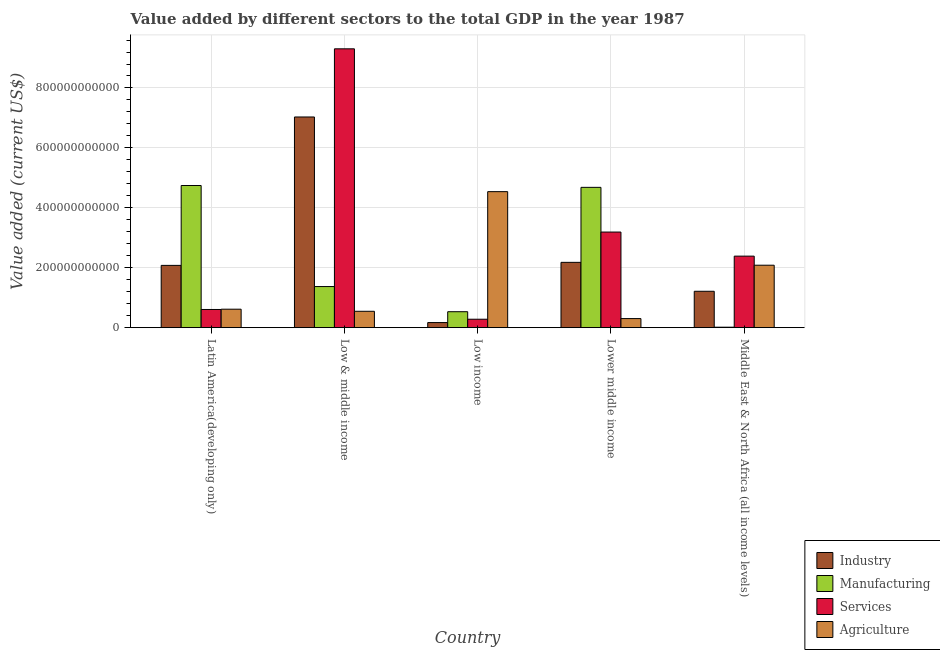How many groups of bars are there?
Your answer should be very brief. 5. How many bars are there on the 3rd tick from the left?
Your answer should be very brief. 4. What is the label of the 1st group of bars from the left?
Your response must be concise. Latin America(developing only). What is the value added by services sector in Middle East & North Africa (all income levels)?
Give a very brief answer. 2.39e+11. Across all countries, what is the maximum value added by industrial sector?
Give a very brief answer. 7.03e+11. Across all countries, what is the minimum value added by agricultural sector?
Give a very brief answer. 3.03e+1. In which country was the value added by agricultural sector maximum?
Give a very brief answer. Low income. In which country was the value added by agricultural sector minimum?
Give a very brief answer. Lower middle income. What is the total value added by manufacturing sector in the graph?
Your answer should be compact. 1.13e+12. What is the difference between the value added by industrial sector in Low & middle income and that in Middle East & North Africa (all income levels)?
Give a very brief answer. 5.82e+11. What is the difference between the value added by services sector in Low income and the value added by manufacturing sector in Middle East & North Africa (all income levels)?
Ensure brevity in your answer.  2.66e+1. What is the average value added by services sector per country?
Give a very brief answer. 3.15e+11. What is the difference between the value added by agricultural sector and value added by services sector in Middle East & North Africa (all income levels)?
Your response must be concise. -3.03e+1. What is the ratio of the value added by agricultural sector in Low & middle income to that in Low income?
Ensure brevity in your answer.  0.12. What is the difference between the highest and the second highest value added by industrial sector?
Offer a terse response. 4.85e+11. What is the difference between the highest and the lowest value added by agricultural sector?
Your answer should be compact. 4.24e+11. In how many countries, is the value added by services sector greater than the average value added by services sector taken over all countries?
Make the answer very short. 2. Is the sum of the value added by manufacturing sector in Low income and Middle East & North Africa (all income levels) greater than the maximum value added by services sector across all countries?
Give a very brief answer. No. Is it the case that in every country, the sum of the value added by services sector and value added by industrial sector is greater than the sum of value added by agricultural sector and value added by manufacturing sector?
Offer a terse response. No. What does the 1st bar from the left in Middle East & North Africa (all income levels) represents?
Provide a succinct answer. Industry. What does the 1st bar from the right in Low & middle income represents?
Your answer should be compact. Agriculture. Are all the bars in the graph horizontal?
Provide a succinct answer. No. How many countries are there in the graph?
Your answer should be very brief. 5. What is the difference between two consecutive major ticks on the Y-axis?
Provide a short and direct response. 2.00e+11. Are the values on the major ticks of Y-axis written in scientific E-notation?
Give a very brief answer. No. How are the legend labels stacked?
Your answer should be compact. Vertical. What is the title of the graph?
Keep it short and to the point. Value added by different sectors to the total GDP in the year 1987. Does "UNRWA" appear as one of the legend labels in the graph?
Your answer should be compact. No. What is the label or title of the X-axis?
Ensure brevity in your answer.  Country. What is the label or title of the Y-axis?
Offer a terse response. Value added (current US$). What is the Value added (current US$) of Industry in Latin America(developing only)?
Make the answer very short. 2.08e+11. What is the Value added (current US$) in Manufacturing in Latin America(developing only)?
Your answer should be compact. 4.74e+11. What is the Value added (current US$) of Services in Latin America(developing only)?
Your answer should be compact. 6.07e+1. What is the Value added (current US$) of Agriculture in Latin America(developing only)?
Give a very brief answer. 6.17e+1. What is the Value added (current US$) of Industry in Low & middle income?
Offer a very short reply. 7.03e+11. What is the Value added (current US$) of Manufacturing in Low & middle income?
Your answer should be compact. 1.37e+11. What is the Value added (current US$) of Services in Low & middle income?
Provide a succinct answer. 9.31e+11. What is the Value added (current US$) of Agriculture in Low & middle income?
Your answer should be very brief. 5.47e+1. What is the Value added (current US$) in Industry in Low income?
Offer a terse response. 1.70e+1. What is the Value added (current US$) of Manufacturing in Low income?
Offer a very short reply. 5.32e+1. What is the Value added (current US$) in Services in Low income?
Your answer should be compact. 2.82e+1. What is the Value added (current US$) in Agriculture in Low income?
Make the answer very short. 4.54e+11. What is the Value added (current US$) of Industry in Lower middle income?
Keep it short and to the point. 2.18e+11. What is the Value added (current US$) in Manufacturing in Lower middle income?
Offer a very short reply. 4.68e+11. What is the Value added (current US$) of Services in Lower middle income?
Give a very brief answer. 3.19e+11. What is the Value added (current US$) of Agriculture in Lower middle income?
Ensure brevity in your answer.  3.03e+1. What is the Value added (current US$) of Industry in Middle East & North Africa (all income levels)?
Your answer should be very brief. 1.21e+11. What is the Value added (current US$) in Manufacturing in Middle East & North Africa (all income levels)?
Your answer should be very brief. 1.57e+09. What is the Value added (current US$) of Services in Middle East & North Africa (all income levels)?
Give a very brief answer. 2.39e+11. What is the Value added (current US$) of Agriculture in Middle East & North Africa (all income levels)?
Your answer should be compact. 2.08e+11. Across all countries, what is the maximum Value added (current US$) of Industry?
Your answer should be compact. 7.03e+11. Across all countries, what is the maximum Value added (current US$) of Manufacturing?
Make the answer very short. 4.74e+11. Across all countries, what is the maximum Value added (current US$) of Services?
Your answer should be compact. 9.31e+11. Across all countries, what is the maximum Value added (current US$) of Agriculture?
Your answer should be compact. 4.54e+11. Across all countries, what is the minimum Value added (current US$) of Industry?
Make the answer very short. 1.70e+1. Across all countries, what is the minimum Value added (current US$) in Manufacturing?
Give a very brief answer. 1.57e+09. Across all countries, what is the minimum Value added (current US$) of Services?
Provide a short and direct response. 2.82e+1. Across all countries, what is the minimum Value added (current US$) in Agriculture?
Provide a short and direct response. 3.03e+1. What is the total Value added (current US$) in Industry in the graph?
Provide a short and direct response. 1.27e+12. What is the total Value added (current US$) in Manufacturing in the graph?
Offer a very short reply. 1.13e+12. What is the total Value added (current US$) in Services in the graph?
Your response must be concise. 1.58e+12. What is the total Value added (current US$) in Agriculture in the graph?
Give a very brief answer. 8.09e+11. What is the difference between the Value added (current US$) of Industry in Latin America(developing only) and that in Low & middle income?
Your answer should be compact. -4.95e+11. What is the difference between the Value added (current US$) in Manufacturing in Latin America(developing only) and that in Low & middle income?
Offer a very short reply. 3.37e+11. What is the difference between the Value added (current US$) in Services in Latin America(developing only) and that in Low & middle income?
Provide a succinct answer. -8.70e+11. What is the difference between the Value added (current US$) of Agriculture in Latin America(developing only) and that in Low & middle income?
Ensure brevity in your answer.  7.00e+09. What is the difference between the Value added (current US$) in Industry in Latin America(developing only) and that in Low income?
Your response must be concise. 1.91e+11. What is the difference between the Value added (current US$) of Manufacturing in Latin America(developing only) and that in Low income?
Offer a very short reply. 4.21e+11. What is the difference between the Value added (current US$) in Services in Latin America(developing only) and that in Low income?
Make the answer very short. 3.25e+1. What is the difference between the Value added (current US$) of Agriculture in Latin America(developing only) and that in Low income?
Provide a short and direct response. -3.92e+11. What is the difference between the Value added (current US$) in Industry in Latin America(developing only) and that in Lower middle income?
Your answer should be very brief. -1.01e+1. What is the difference between the Value added (current US$) in Manufacturing in Latin America(developing only) and that in Lower middle income?
Keep it short and to the point. 6.17e+09. What is the difference between the Value added (current US$) in Services in Latin America(developing only) and that in Lower middle income?
Make the answer very short. -2.58e+11. What is the difference between the Value added (current US$) of Agriculture in Latin America(developing only) and that in Lower middle income?
Provide a succinct answer. 3.14e+1. What is the difference between the Value added (current US$) in Industry in Latin America(developing only) and that in Middle East & North Africa (all income levels)?
Keep it short and to the point. 8.64e+1. What is the difference between the Value added (current US$) in Manufacturing in Latin America(developing only) and that in Middle East & North Africa (all income levels)?
Make the answer very short. 4.73e+11. What is the difference between the Value added (current US$) in Services in Latin America(developing only) and that in Middle East & North Africa (all income levels)?
Your response must be concise. -1.78e+11. What is the difference between the Value added (current US$) of Agriculture in Latin America(developing only) and that in Middle East & North Africa (all income levels)?
Keep it short and to the point. -1.47e+11. What is the difference between the Value added (current US$) of Industry in Low & middle income and that in Low income?
Your response must be concise. 6.86e+11. What is the difference between the Value added (current US$) of Manufacturing in Low & middle income and that in Low income?
Give a very brief answer. 8.40e+1. What is the difference between the Value added (current US$) in Services in Low & middle income and that in Low income?
Make the answer very short. 9.03e+11. What is the difference between the Value added (current US$) of Agriculture in Low & middle income and that in Low income?
Provide a short and direct response. -3.99e+11. What is the difference between the Value added (current US$) of Industry in Low & middle income and that in Lower middle income?
Your response must be concise. 4.85e+11. What is the difference between the Value added (current US$) in Manufacturing in Low & middle income and that in Lower middle income?
Ensure brevity in your answer.  -3.31e+11. What is the difference between the Value added (current US$) of Services in Low & middle income and that in Lower middle income?
Ensure brevity in your answer.  6.12e+11. What is the difference between the Value added (current US$) in Agriculture in Low & middle income and that in Lower middle income?
Provide a succinct answer. 2.44e+1. What is the difference between the Value added (current US$) in Industry in Low & middle income and that in Middle East & North Africa (all income levels)?
Ensure brevity in your answer.  5.82e+11. What is the difference between the Value added (current US$) in Manufacturing in Low & middle income and that in Middle East & North Africa (all income levels)?
Your response must be concise. 1.36e+11. What is the difference between the Value added (current US$) in Services in Low & middle income and that in Middle East & North Africa (all income levels)?
Your answer should be compact. 6.92e+11. What is the difference between the Value added (current US$) in Agriculture in Low & middle income and that in Middle East & North Africa (all income levels)?
Keep it short and to the point. -1.54e+11. What is the difference between the Value added (current US$) of Industry in Low income and that in Lower middle income?
Make the answer very short. -2.01e+11. What is the difference between the Value added (current US$) of Manufacturing in Low income and that in Lower middle income?
Provide a succinct answer. -4.15e+11. What is the difference between the Value added (current US$) of Services in Low income and that in Lower middle income?
Provide a succinct answer. -2.91e+11. What is the difference between the Value added (current US$) of Agriculture in Low income and that in Lower middle income?
Offer a terse response. 4.24e+11. What is the difference between the Value added (current US$) in Industry in Low income and that in Middle East & North Africa (all income levels)?
Your answer should be compact. -1.04e+11. What is the difference between the Value added (current US$) in Manufacturing in Low income and that in Middle East & North Africa (all income levels)?
Your answer should be very brief. 5.17e+1. What is the difference between the Value added (current US$) in Services in Low income and that in Middle East & North Africa (all income levels)?
Provide a succinct answer. -2.11e+11. What is the difference between the Value added (current US$) in Agriculture in Low income and that in Middle East & North Africa (all income levels)?
Keep it short and to the point. 2.46e+11. What is the difference between the Value added (current US$) of Industry in Lower middle income and that in Middle East & North Africa (all income levels)?
Provide a short and direct response. 9.65e+1. What is the difference between the Value added (current US$) in Manufacturing in Lower middle income and that in Middle East & North Africa (all income levels)?
Offer a very short reply. 4.67e+11. What is the difference between the Value added (current US$) of Services in Lower middle income and that in Middle East & North Africa (all income levels)?
Your answer should be very brief. 8.04e+1. What is the difference between the Value added (current US$) in Agriculture in Lower middle income and that in Middle East & North Africa (all income levels)?
Your answer should be compact. -1.78e+11. What is the difference between the Value added (current US$) of Industry in Latin America(developing only) and the Value added (current US$) of Manufacturing in Low & middle income?
Your answer should be very brief. 7.07e+1. What is the difference between the Value added (current US$) of Industry in Latin America(developing only) and the Value added (current US$) of Services in Low & middle income?
Ensure brevity in your answer.  -7.23e+11. What is the difference between the Value added (current US$) of Industry in Latin America(developing only) and the Value added (current US$) of Agriculture in Low & middle income?
Your response must be concise. 1.53e+11. What is the difference between the Value added (current US$) of Manufacturing in Latin America(developing only) and the Value added (current US$) of Services in Low & middle income?
Provide a succinct answer. -4.56e+11. What is the difference between the Value added (current US$) of Manufacturing in Latin America(developing only) and the Value added (current US$) of Agriculture in Low & middle income?
Your answer should be compact. 4.20e+11. What is the difference between the Value added (current US$) of Services in Latin America(developing only) and the Value added (current US$) of Agriculture in Low & middle income?
Your response must be concise. 6.03e+09. What is the difference between the Value added (current US$) in Industry in Latin America(developing only) and the Value added (current US$) in Manufacturing in Low income?
Ensure brevity in your answer.  1.55e+11. What is the difference between the Value added (current US$) of Industry in Latin America(developing only) and the Value added (current US$) of Services in Low income?
Ensure brevity in your answer.  1.80e+11. What is the difference between the Value added (current US$) in Industry in Latin America(developing only) and the Value added (current US$) in Agriculture in Low income?
Provide a succinct answer. -2.46e+11. What is the difference between the Value added (current US$) in Manufacturing in Latin America(developing only) and the Value added (current US$) in Services in Low income?
Make the answer very short. 4.46e+11. What is the difference between the Value added (current US$) of Manufacturing in Latin America(developing only) and the Value added (current US$) of Agriculture in Low income?
Your answer should be very brief. 2.05e+1. What is the difference between the Value added (current US$) in Services in Latin America(developing only) and the Value added (current US$) in Agriculture in Low income?
Offer a terse response. -3.93e+11. What is the difference between the Value added (current US$) of Industry in Latin America(developing only) and the Value added (current US$) of Manufacturing in Lower middle income?
Your answer should be compact. -2.60e+11. What is the difference between the Value added (current US$) of Industry in Latin America(developing only) and the Value added (current US$) of Services in Lower middle income?
Offer a very short reply. -1.11e+11. What is the difference between the Value added (current US$) of Industry in Latin America(developing only) and the Value added (current US$) of Agriculture in Lower middle income?
Make the answer very short. 1.78e+11. What is the difference between the Value added (current US$) of Manufacturing in Latin America(developing only) and the Value added (current US$) of Services in Lower middle income?
Provide a succinct answer. 1.55e+11. What is the difference between the Value added (current US$) of Manufacturing in Latin America(developing only) and the Value added (current US$) of Agriculture in Lower middle income?
Your answer should be very brief. 4.44e+11. What is the difference between the Value added (current US$) in Services in Latin America(developing only) and the Value added (current US$) in Agriculture in Lower middle income?
Keep it short and to the point. 3.04e+1. What is the difference between the Value added (current US$) of Industry in Latin America(developing only) and the Value added (current US$) of Manufacturing in Middle East & North Africa (all income levels)?
Ensure brevity in your answer.  2.06e+11. What is the difference between the Value added (current US$) of Industry in Latin America(developing only) and the Value added (current US$) of Services in Middle East & North Africa (all income levels)?
Provide a short and direct response. -3.08e+1. What is the difference between the Value added (current US$) of Industry in Latin America(developing only) and the Value added (current US$) of Agriculture in Middle East & North Africa (all income levels)?
Your answer should be compact. -5.55e+08. What is the difference between the Value added (current US$) in Manufacturing in Latin America(developing only) and the Value added (current US$) in Services in Middle East & North Africa (all income levels)?
Your response must be concise. 2.36e+11. What is the difference between the Value added (current US$) in Manufacturing in Latin America(developing only) and the Value added (current US$) in Agriculture in Middle East & North Africa (all income levels)?
Provide a succinct answer. 2.66e+11. What is the difference between the Value added (current US$) of Services in Latin America(developing only) and the Value added (current US$) of Agriculture in Middle East & North Africa (all income levels)?
Offer a very short reply. -1.48e+11. What is the difference between the Value added (current US$) in Industry in Low & middle income and the Value added (current US$) in Manufacturing in Low income?
Make the answer very short. 6.50e+11. What is the difference between the Value added (current US$) of Industry in Low & middle income and the Value added (current US$) of Services in Low income?
Give a very brief answer. 6.75e+11. What is the difference between the Value added (current US$) of Industry in Low & middle income and the Value added (current US$) of Agriculture in Low income?
Provide a succinct answer. 2.49e+11. What is the difference between the Value added (current US$) of Manufacturing in Low & middle income and the Value added (current US$) of Services in Low income?
Your response must be concise. 1.09e+11. What is the difference between the Value added (current US$) of Manufacturing in Low & middle income and the Value added (current US$) of Agriculture in Low income?
Your answer should be compact. -3.17e+11. What is the difference between the Value added (current US$) in Services in Low & middle income and the Value added (current US$) in Agriculture in Low income?
Make the answer very short. 4.77e+11. What is the difference between the Value added (current US$) in Industry in Low & middle income and the Value added (current US$) in Manufacturing in Lower middle income?
Offer a very short reply. 2.35e+11. What is the difference between the Value added (current US$) of Industry in Low & middle income and the Value added (current US$) of Services in Lower middle income?
Offer a terse response. 3.84e+11. What is the difference between the Value added (current US$) of Industry in Low & middle income and the Value added (current US$) of Agriculture in Lower middle income?
Offer a terse response. 6.73e+11. What is the difference between the Value added (current US$) in Manufacturing in Low & middle income and the Value added (current US$) in Services in Lower middle income?
Your answer should be very brief. -1.82e+11. What is the difference between the Value added (current US$) in Manufacturing in Low & middle income and the Value added (current US$) in Agriculture in Lower middle income?
Your answer should be compact. 1.07e+11. What is the difference between the Value added (current US$) in Services in Low & middle income and the Value added (current US$) in Agriculture in Lower middle income?
Give a very brief answer. 9.00e+11. What is the difference between the Value added (current US$) in Industry in Low & middle income and the Value added (current US$) in Manufacturing in Middle East & North Africa (all income levels)?
Make the answer very short. 7.02e+11. What is the difference between the Value added (current US$) in Industry in Low & middle income and the Value added (current US$) in Services in Middle East & North Africa (all income levels)?
Your answer should be very brief. 4.64e+11. What is the difference between the Value added (current US$) in Industry in Low & middle income and the Value added (current US$) in Agriculture in Middle East & North Africa (all income levels)?
Offer a very short reply. 4.95e+11. What is the difference between the Value added (current US$) in Manufacturing in Low & middle income and the Value added (current US$) in Services in Middle East & North Africa (all income levels)?
Provide a short and direct response. -1.02e+11. What is the difference between the Value added (current US$) in Manufacturing in Low & middle income and the Value added (current US$) in Agriculture in Middle East & North Africa (all income levels)?
Your response must be concise. -7.12e+1. What is the difference between the Value added (current US$) in Services in Low & middle income and the Value added (current US$) in Agriculture in Middle East & North Africa (all income levels)?
Provide a short and direct response. 7.22e+11. What is the difference between the Value added (current US$) of Industry in Low income and the Value added (current US$) of Manufacturing in Lower middle income?
Offer a terse response. -4.51e+11. What is the difference between the Value added (current US$) in Industry in Low income and the Value added (current US$) in Services in Lower middle income?
Provide a short and direct response. -3.02e+11. What is the difference between the Value added (current US$) of Industry in Low income and the Value added (current US$) of Agriculture in Lower middle income?
Offer a terse response. -1.33e+1. What is the difference between the Value added (current US$) in Manufacturing in Low income and the Value added (current US$) in Services in Lower middle income?
Your answer should be very brief. -2.66e+11. What is the difference between the Value added (current US$) in Manufacturing in Low income and the Value added (current US$) in Agriculture in Lower middle income?
Give a very brief answer. 2.29e+1. What is the difference between the Value added (current US$) in Services in Low income and the Value added (current US$) in Agriculture in Lower middle income?
Your answer should be compact. -2.13e+09. What is the difference between the Value added (current US$) of Industry in Low income and the Value added (current US$) of Manufacturing in Middle East & North Africa (all income levels)?
Offer a terse response. 1.54e+1. What is the difference between the Value added (current US$) of Industry in Low income and the Value added (current US$) of Services in Middle East & North Africa (all income levels)?
Make the answer very short. -2.22e+11. What is the difference between the Value added (current US$) of Industry in Low income and the Value added (current US$) of Agriculture in Middle East & North Africa (all income levels)?
Offer a terse response. -1.91e+11. What is the difference between the Value added (current US$) in Manufacturing in Low income and the Value added (current US$) in Services in Middle East & North Africa (all income levels)?
Give a very brief answer. -1.85e+11. What is the difference between the Value added (current US$) of Manufacturing in Low income and the Value added (current US$) of Agriculture in Middle East & North Africa (all income levels)?
Offer a very short reply. -1.55e+11. What is the difference between the Value added (current US$) in Services in Low income and the Value added (current US$) in Agriculture in Middle East & North Africa (all income levels)?
Offer a very short reply. -1.80e+11. What is the difference between the Value added (current US$) in Industry in Lower middle income and the Value added (current US$) in Manufacturing in Middle East & North Africa (all income levels)?
Your answer should be very brief. 2.16e+11. What is the difference between the Value added (current US$) of Industry in Lower middle income and the Value added (current US$) of Services in Middle East & North Africa (all income levels)?
Make the answer very short. -2.07e+1. What is the difference between the Value added (current US$) in Industry in Lower middle income and the Value added (current US$) in Agriculture in Middle East & North Africa (all income levels)?
Your answer should be very brief. 9.55e+09. What is the difference between the Value added (current US$) in Manufacturing in Lower middle income and the Value added (current US$) in Services in Middle East & North Africa (all income levels)?
Keep it short and to the point. 2.30e+11. What is the difference between the Value added (current US$) in Manufacturing in Lower middle income and the Value added (current US$) in Agriculture in Middle East & North Africa (all income levels)?
Ensure brevity in your answer.  2.60e+11. What is the difference between the Value added (current US$) of Services in Lower middle income and the Value added (current US$) of Agriculture in Middle East & North Africa (all income levels)?
Offer a very short reply. 1.11e+11. What is the average Value added (current US$) in Industry per country?
Offer a terse response. 2.54e+11. What is the average Value added (current US$) in Manufacturing per country?
Ensure brevity in your answer.  2.27e+11. What is the average Value added (current US$) in Services per country?
Ensure brevity in your answer.  3.15e+11. What is the average Value added (current US$) in Agriculture per country?
Give a very brief answer. 1.62e+11. What is the difference between the Value added (current US$) of Industry and Value added (current US$) of Manufacturing in Latin America(developing only)?
Offer a very short reply. -2.67e+11. What is the difference between the Value added (current US$) of Industry and Value added (current US$) of Services in Latin America(developing only)?
Give a very brief answer. 1.47e+11. What is the difference between the Value added (current US$) of Industry and Value added (current US$) of Agriculture in Latin America(developing only)?
Give a very brief answer. 1.46e+11. What is the difference between the Value added (current US$) in Manufacturing and Value added (current US$) in Services in Latin America(developing only)?
Your response must be concise. 4.14e+11. What is the difference between the Value added (current US$) of Manufacturing and Value added (current US$) of Agriculture in Latin America(developing only)?
Your answer should be compact. 4.13e+11. What is the difference between the Value added (current US$) of Services and Value added (current US$) of Agriculture in Latin America(developing only)?
Offer a terse response. -9.75e+08. What is the difference between the Value added (current US$) in Industry and Value added (current US$) in Manufacturing in Low & middle income?
Provide a succinct answer. 5.66e+11. What is the difference between the Value added (current US$) in Industry and Value added (current US$) in Services in Low & middle income?
Make the answer very short. -2.28e+11. What is the difference between the Value added (current US$) of Industry and Value added (current US$) of Agriculture in Low & middle income?
Your answer should be compact. 6.49e+11. What is the difference between the Value added (current US$) of Manufacturing and Value added (current US$) of Services in Low & middle income?
Your response must be concise. -7.93e+11. What is the difference between the Value added (current US$) in Manufacturing and Value added (current US$) in Agriculture in Low & middle income?
Make the answer very short. 8.26e+1. What is the difference between the Value added (current US$) of Services and Value added (current US$) of Agriculture in Low & middle income?
Give a very brief answer. 8.76e+11. What is the difference between the Value added (current US$) in Industry and Value added (current US$) in Manufacturing in Low income?
Make the answer very short. -3.62e+1. What is the difference between the Value added (current US$) in Industry and Value added (current US$) in Services in Low income?
Your response must be concise. -1.12e+1. What is the difference between the Value added (current US$) of Industry and Value added (current US$) of Agriculture in Low income?
Give a very brief answer. -4.37e+11. What is the difference between the Value added (current US$) in Manufacturing and Value added (current US$) in Services in Low income?
Give a very brief answer. 2.51e+1. What is the difference between the Value added (current US$) of Manufacturing and Value added (current US$) of Agriculture in Low income?
Provide a short and direct response. -4.01e+11. What is the difference between the Value added (current US$) of Services and Value added (current US$) of Agriculture in Low income?
Make the answer very short. -4.26e+11. What is the difference between the Value added (current US$) in Industry and Value added (current US$) in Manufacturing in Lower middle income?
Keep it short and to the point. -2.50e+11. What is the difference between the Value added (current US$) in Industry and Value added (current US$) in Services in Lower middle income?
Keep it short and to the point. -1.01e+11. What is the difference between the Value added (current US$) in Industry and Value added (current US$) in Agriculture in Lower middle income?
Provide a short and direct response. 1.88e+11. What is the difference between the Value added (current US$) in Manufacturing and Value added (current US$) in Services in Lower middle income?
Make the answer very short. 1.49e+11. What is the difference between the Value added (current US$) of Manufacturing and Value added (current US$) of Agriculture in Lower middle income?
Make the answer very short. 4.38e+11. What is the difference between the Value added (current US$) in Services and Value added (current US$) in Agriculture in Lower middle income?
Your response must be concise. 2.89e+11. What is the difference between the Value added (current US$) of Industry and Value added (current US$) of Manufacturing in Middle East & North Africa (all income levels)?
Your answer should be compact. 1.20e+11. What is the difference between the Value added (current US$) of Industry and Value added (current US$) of Services in Middle East & North Africa (all income levels)?
Your answer should be very brief. -1.17e+11. What is the difference between the Value added (current US$) in Industry and Value added (current US$) in Agriculture in Middle East & North Africa (all income levels)?
Your answer should be very brief. -8.70e+1. What is the difference between the Value added (current US$) in Manufacturing and Value added (current US$) in Services in Middle East & North Africa (all income levels)?
Give a very brief answer. -2.37e+11. What is the difference between the Value added (current US$) of Manufacturing and Value added (current US$) of Agriculture in Middle East & North Africa (all income levels)?
Ensure brevity in your answer.  -2.07e+11. What is the difference between the Value added (current US$) in Services and Value added (current US$) in Agriculture in Middle East & North Africa (all income levels)?
Your answer should be compact. 3.03e+1. What is the ratio of the Value added (current US$) of Industry in Latin America(developing only) to that in Low & middle income?
Offer a terse response. 0.3. What is the ratio of the Value added (current US$) of Manufacturing in Latin America(developing only) to that in Low & middle income?
Your answer should be compact. 3.46. What is the ratio of the Value added (current US$) in Services in Latin America(developing only) to that in Low & middle income?
Keep it short and to the point. 0.07. What is the ratio of the Value added (current US$) of Agriculture in Latin America(developing only) to that in Low & middle income?
Offer a terse response. 1.13. What is the ratio of the Value added (current US$) of Industry in Latin America(developing only) to that in Low income?
Ensure brevity in your answer.  12.22. What is the ratio of the Value added (current US$) in Manufacturing in Latin America(developing only) to that in Low income?
Give a very brief answer. 8.91. What is the ratio of the Value added (current US$) of Services in Latin America(developing only) to that in Low income?
Your answer should be very brief. 2.15. What is the ratio of the Value added (current US$) in Agriculture in Latin America(developing only) to that in Low income?
Provide a succinct answer. 0.14. What is the ratio of the Value added (current US$) in Industry in Latin America(developing only) to that in Lower middle income?
Offer a very short reply. 0.95. What is the ratio of the Value added (current US$) in Manufacturing in Latin America(developing only) to that in Lower middle income?
Make the answer very short. 1.01. What is the ratio of the Value added (current US$) of Services in Latin America(developing only) to that in Lower middle income?
Ensure brevity in your answer.  0.19. What is the ratio of the Value added (current US$) of Agriculture in Latin America(developing only) to that in Lower middle income?
Offer a terse response. 2.03. What is the ratio of the Value added (current US$) of Industry in Latin America(developing only) to that in Middle East & North Africa (all income levels)?
Your answer should be very brief. 1.71. What is the ratio of the Value added (current US$) of Manufacturing in Latin America(developing only) to that in Middle East & North Africa (all income levels)?
Make the answer very short. 301.3. What is the ratio of the Value added (current US$) in Services in Latin America(developing only) to that in Middle East & North Africa (all income levels)?
Offer a terse response. 0.25. What is the ratio of the Value added (current US$) of Agriculture in Latin America(developing only) to that in Middle East & North Africa (all income levels)?
Make the answer very short. 0.3. What is the ratio of the Value added (current US$) in Industry in Low & middle income to that in Low income?
Provide a short and direct response. 41.33. What is the ratio of the Value added (current US$) in Manufacturing in Low & middle income to that in Low income?
Give a very brief answer. 2.58. What is the ratio of the Value added (current US$) of Services in Low & middle income to that in Low income?
Provide a succinct answer. 33.03. What is the ratio of the Value added (current US$) of Agriculture in Low & middle income to that in Low income?
Provide a succinct answer. 0.12. What is the ratio of the Value added (current US$) of Industry in Low & middle income to that in Lower middle income?
Provide a succinct answer. 3.23. What is the ratio of the Value added (current US$) in Manufacturing in Low & middle income to that in Lower middle income?
Give a very brief answer. 0.29. What is the ratio of the Value added (current US$) of Services in Low & middle income to that in Lower middle income?
Ensure brevity in your answer.  2.92. What is the ratio of the Value added (current US$) in Agriculture in Low & middle income to that in Lower middle income?
Your answer should be compact. 1.8. What is the ratio of the Value added (current US$) of Industry in Low & middle income to that in Middle East & North Africa (all income levels)?
Offer a very short reply. 5.79. What is the ratio of the Value added (current US$) in Manufacturing in Low & middle income to that in Middle East & North Africa (all income levels)?
Ensure brevity in your answer.  87.14. What is the ratio of the Value added (current US$) of Services in Low & middle income to that in Middle East & North Africa (all income levels)?
Offer a very short reply. 3.9. What is the ratio of the Value added (current US$) of Agriculture in Low & middle income to that in Middle East & North Africa (all income levels)?
Your answer should be very brief. 0.26. What is the ratio of the Value added (current US$) of Industry in Low income to that in Lower middle income?
Provide a short and direct response. 0.08. What is the ratio of the Value added (current US$) of Manufacturing in Low income to that in Lower middle income?
Your response must be concise. 0.11. What is the ratio of the Value added (current US$) of Services in Low income to that in Lower middle income?
Offer a terse response. 0.09. What is the ratio of the Value added (current US$) in Agriculture in Low income to that in Lower middle income?
Offer a terse response. 14.98. What is the ratio of the Value added (current US$) in Industry in Low income to that in Middle East & North Africa (all income levels)?
Your answer should be compact. 0.14. What is the ratio of the Value added (current US$) of Manufacturing in Low income to that in Middle East & North Africa (all income levels)?
Make the answer very short. 33.81. What is the ratio of the Value added (current US$) in Services in Low income to that in Middle East & North Africa (all income levels)?
Ensure brevity in your answer.  0.12. What is the ratio of the Value added (current US$) of Agriculture in Low income to that in Middle East & North Africa (all income levels)?
Your answer should be very brief. 2.18. What is the ratio of the Value added (current US$) of Industry in Lower middle income to that in Middle East & North Africa (all income levels)?
Give a very brief answer. 1.79. What is the ratio of the Value added (current US$) in Manufacturing in Lower middle income to that in Middle East & North Africa (all income levels)?
Offer a terse response. 297.38. What is the ratio of the Value added (current US$) of Services in Lower middle income to that in Middle East & North Africa (all income levels)?
Offer a very short reply. 1.34. What is the ratio of the Value added (current US$) in Agriculture in Lower middle income to that in Middle East & North Africa (all income levels)?
Make the answer very short. 0.15. What is the difference between the highest and the second highest Value added (current US$) in Industry?
Your response must be concise. 4.85e+11. What is the difference between the highest and the second highest Value added (current US$) in Manufacturing?
Give a very brief answer. 6.17e+09. What is the difference between the highest and the second highest Value added (current US$) in Services?
Keep it short and to the point. 6.12e+11. What is the difference between the highest and the second highest Value added (current US$) of Agriculture?
Keep it short and to the point. 2.46e+11. What is the difference between the highest and the lowest Value added (current US$) in Industry?
Offer a very short reply. 6.86e+11. What is the difference between the highest and the lowest Value added (current US$) in Manufacturing?
Ensure brevity in your answer.  4.73e+11. What is the difference between the highest and the lowest Value added (current US$) of Services?
Your answer should be very brief. 9.03e+11. What is the difference between the highest and the lowest Value added (current US$) of Agriculture?
Make the answer very short. 4.24e+11. 